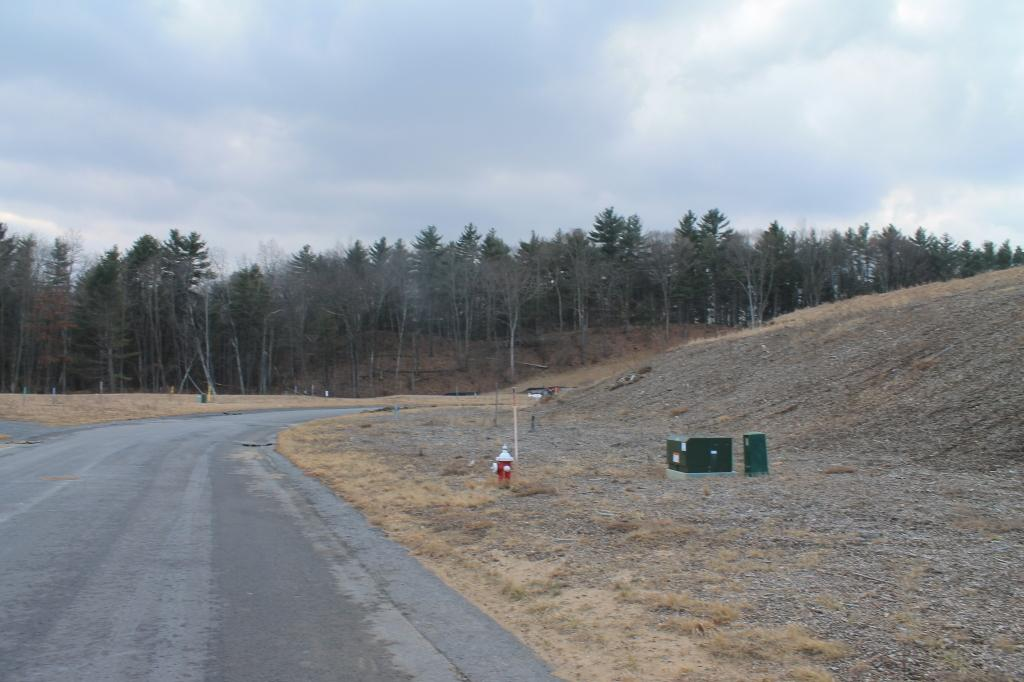What is the main feature of the image? There is a road in the image. What objects can be seen on the right side of the image? There are two boxes and a fire hydrant on the right side of the image. What can be seen in the background of the image? There are many trees and clouds visible in the background of the image, and the sky is also visible. What type of cactus can be seen growing on the side of the road in the image? There is no cactus visible in the image; the background features trees instead. What kind of meat is being grilled on the side of the road in the image? There is no meat or grilling activity present in the image. 